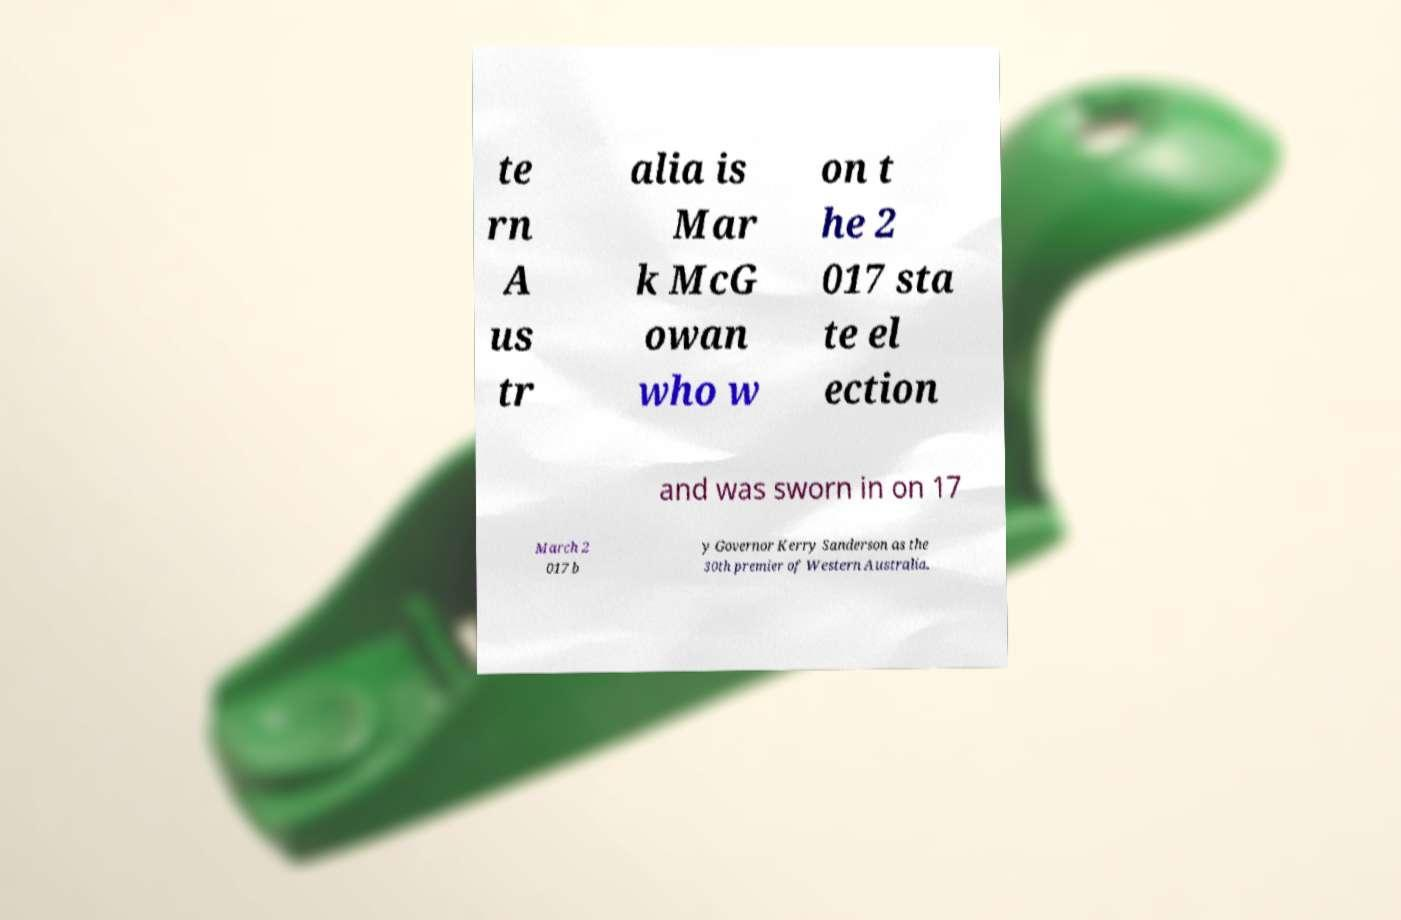Could you extract and type out the text from this image? te rn A us tr alia is Mar k McG owan who w on t he 2 017 sta te el ection and was sworn in on 17 March 2 017 b y Governor Kerry Sanderson as the 30th premier of Western Australia. 